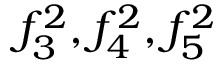<formula> <loc_0><loc_0><loc_500><loc_500>f _ { 3 } ^ { 2 } , f _ { 4 } ^ { 2 } , f _ { 5 } ^ { 2 }</formula> 